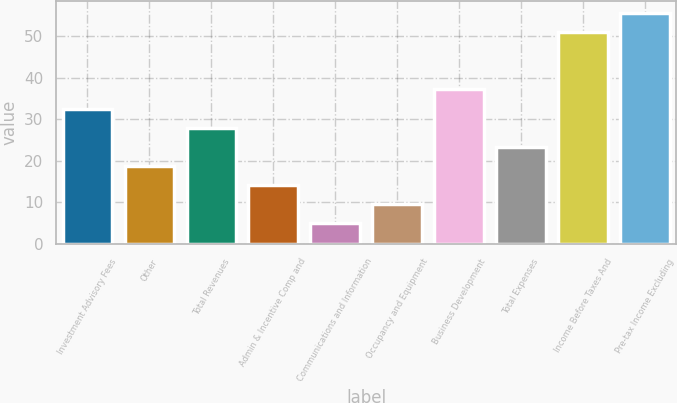<chart> <loc_0><loc_0><loc_500><loc_500><bar_chart><fcel>Investment Advisory Fees<fcel>Other<fcel>Total Revenues<fcel>Admin & Incentive Comp and<fcel>Communications and Information<fcel>Occupancy and Equipment<fcel>Business Development<fcel>Total Expenses<fcel>Income Before Taxes And<fcel>Pre-tax Income Excluding<nl><fcel>32.6<fcel>18.8<fcel>28<fcel>14.2<fcel>5<fcel>9.6<fcel>37.2<fcel>23.4<fcel>51<fcel>55.6<nl></chart> 